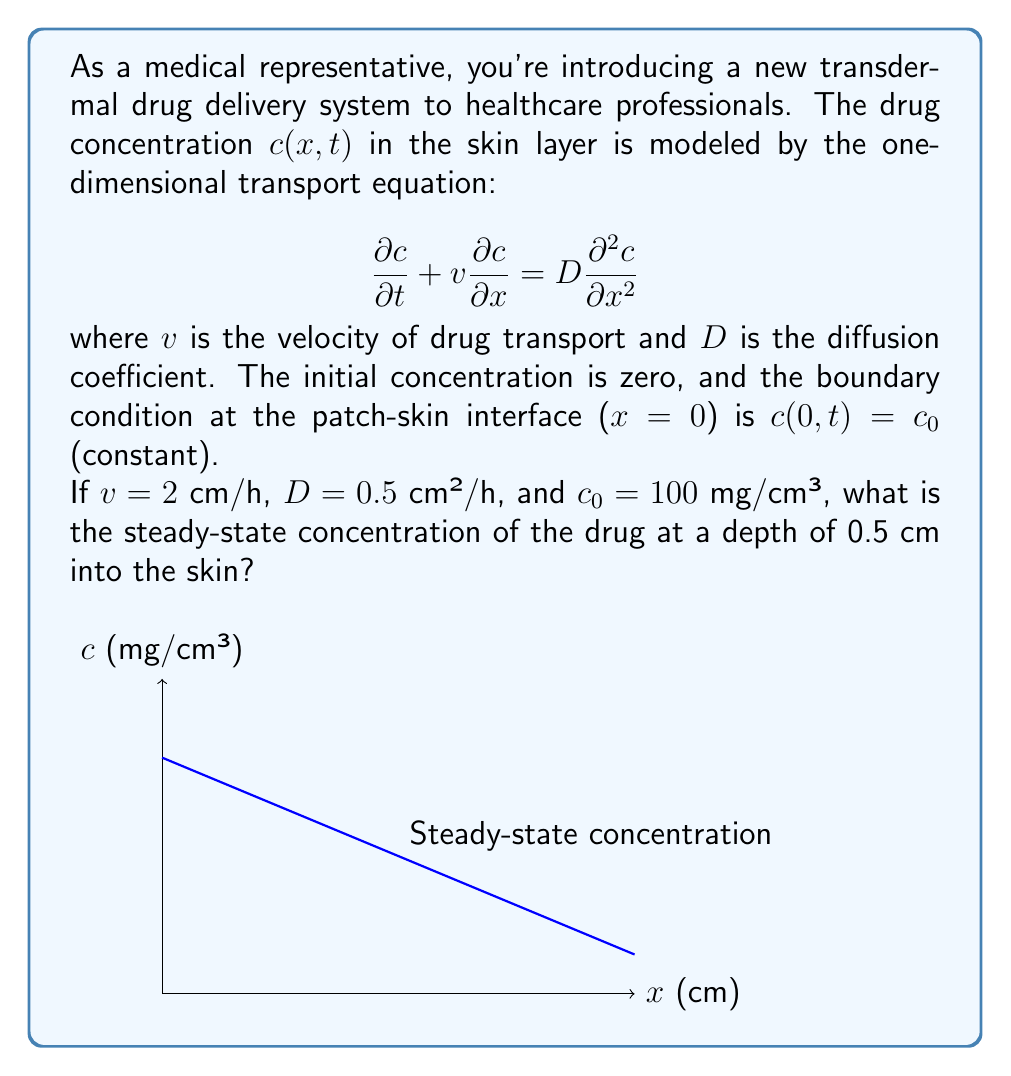Could you help me with this problem? Let's approach this step-by-step:

1) For the steady-state solution, the concentration doesn't change with time. So, we set $\frac{\partial c}{\partial t} = 0$:

   $$v\frac{\partial c}{\partial x} = D\frac{\partial^2 c}{\partial x^2}$$

2) This is a second-order ODE. Its general solution is:

   $$c(x) = A + Be^{\frac{v}{D}x}$$

   where $A$ and $B$ are constants to be determined.

3) We have two boundary conditions:
   a) At $x=0$, $c(0) = c_0 = 100$ mg/cm³
   b) As $x \to \infty$, $c(\infty)$ should be finite

4) Applying condition (b), we must have $B=0$ (otherwise, the exponential term would grow unboundedly). So our solution simplifies to:

   $$c(x) = A$$

5) Applying condition (a):

   $$c(0) = A = c_0 = 100 \text{ mg/cm³}$$

6) Therefore, the steady-state solution is a constant concentration equal to the boundary concentration:

   $$c(x) = 100 \text{ mg/cm³}$$

7) At $x = 0.5$ cm, the concentration is still 100 mg/cm³.

Note: In this steady-state solution, the advection (represented by $v$) and diffusion (represented by $D$) balance each other, resulting in a uniform concentration throughout the skin layer.
Answer: 100 mg/cm³ 